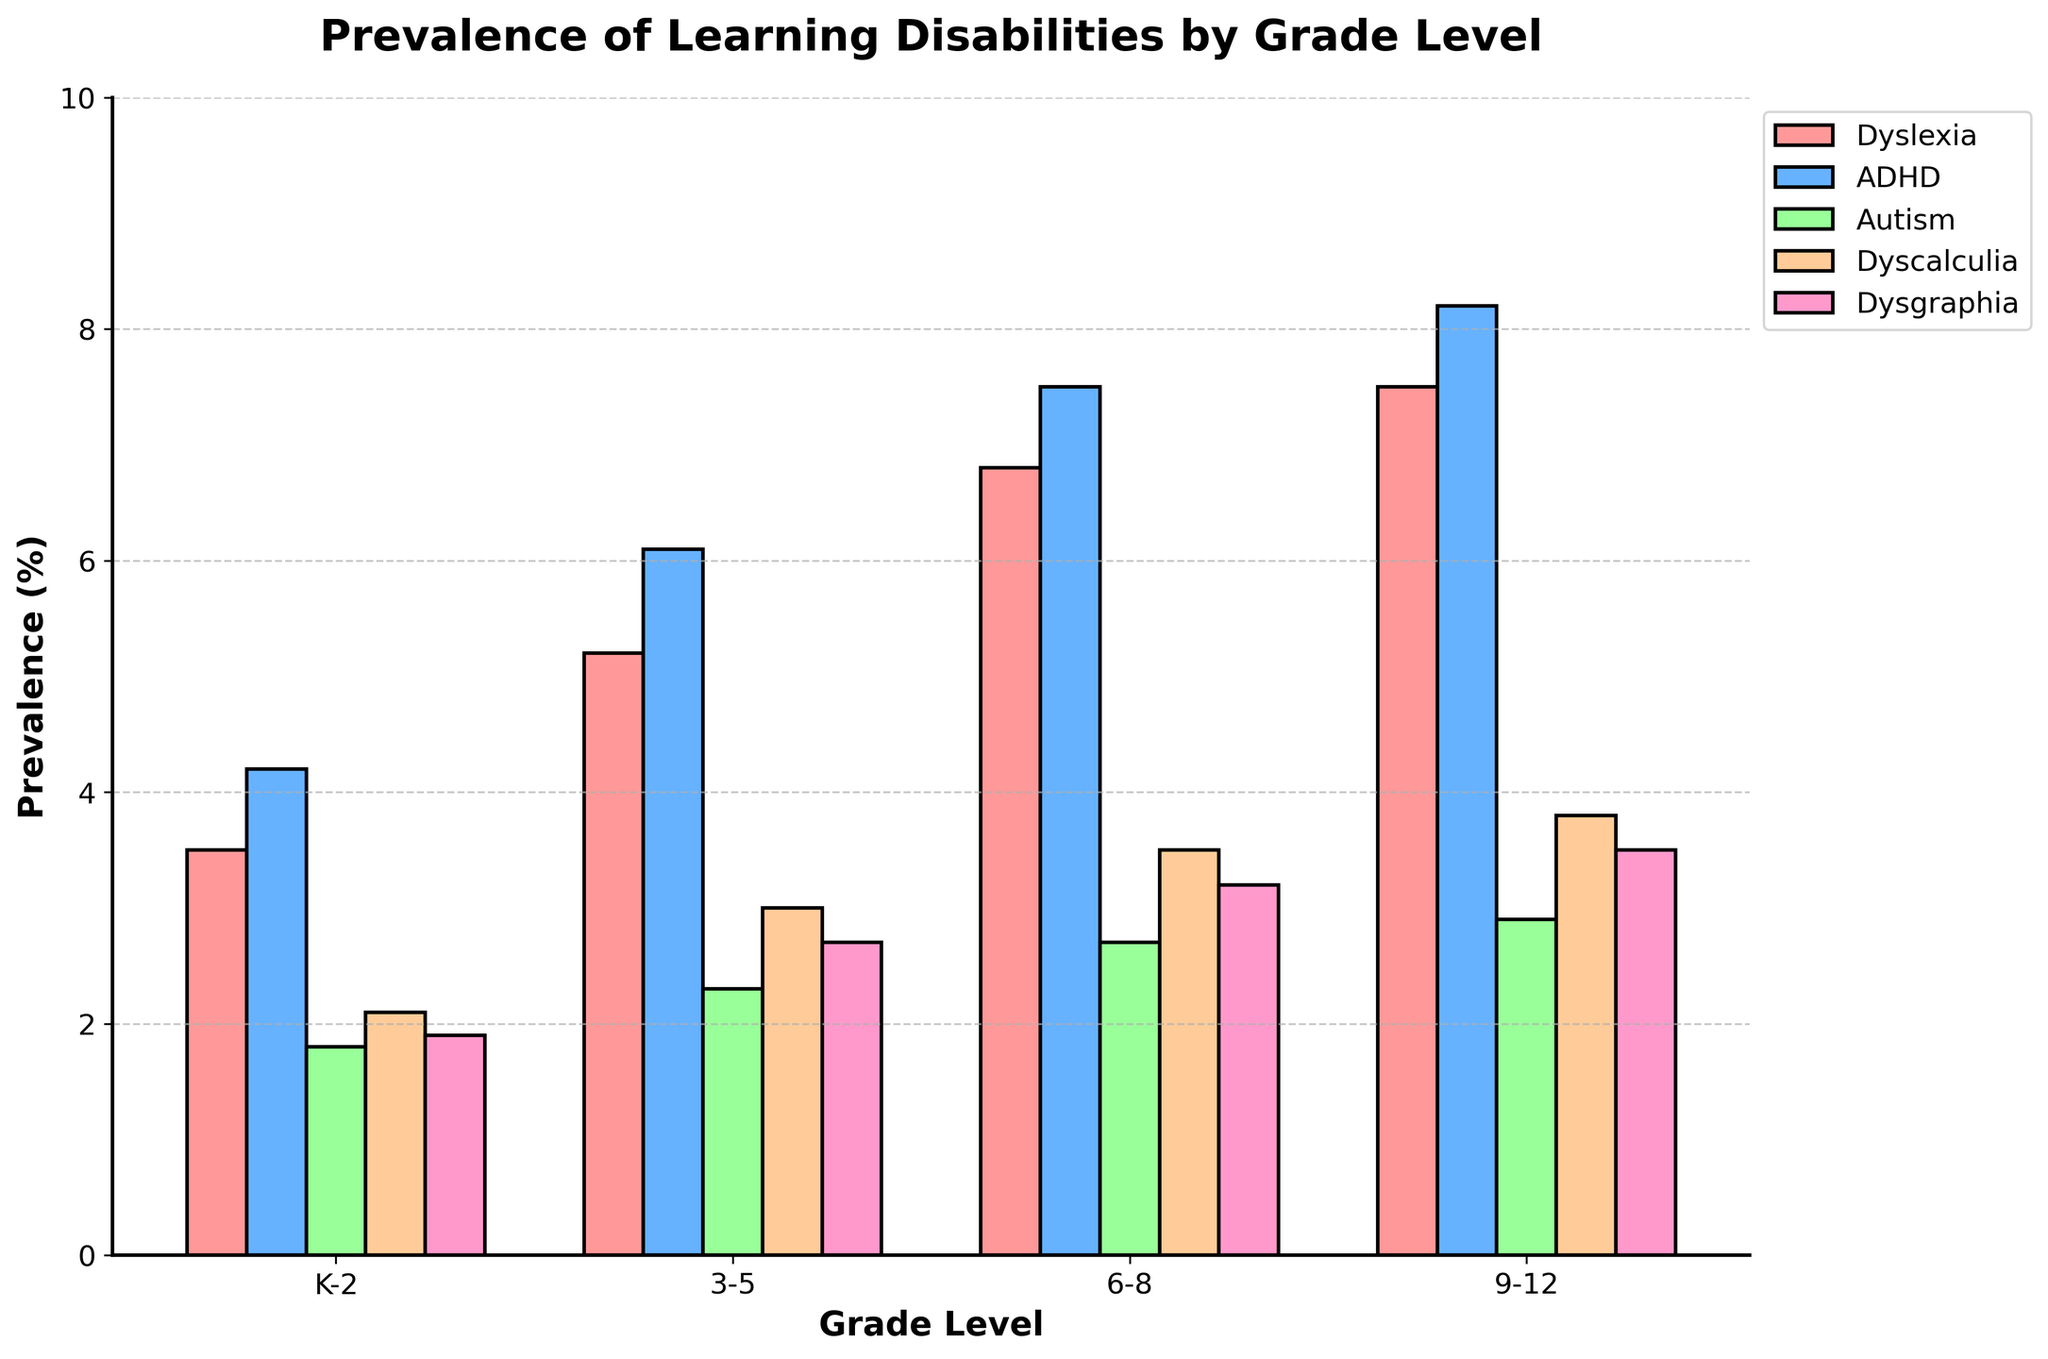What grade level has the highest prevalence of Dyslexia? By observing the height of the bars for Dyslexia across different grade levels, we see that the bar corresponding to grade level 9-12 is the tallest.
Answer: 9-12 How does the prevalence of ADHD change from grade level K-2 to 9-12? The bar for ADHD in grade level K-2 is at 4.2%, and in grade level 9-12, it is at 8.2%. Therefore, the prevalence increases by 8.2% - 4.2%, which is 4%.
Answer: 4% Compare the prevalence of Autism in grade levels K-2 and 9-12. The height of the bar for Autism in grade K-2 is 1.8%, and in grade level 9-12, it is 2.9%. Therefore, the prevalence in grade level 9-12 is higher by 2.9% - 1.8%, which is 1.1%.
Answer: 1.1% Which learning disability has the highest overall prevalence in any grade level? By comparing the highest bars across all categories, we find that the bar for ADHD in grade level 9-12 is the tallest at 8.2%.
Answer: ADHD What is the average prevalence of Dyscalculia across all grade levels? Adding up the Dyscalculia values: 2.1 + 3.0 + 3.5 + 3.8 = 12.4. There are 4 grade levels, so the average is 12.4 / 4 = 3.1%.
Answer: 3.1% Which grade level has the most evenly distributed prevalence of learning disabilities? To determine this, we observe the bars' relative heights for each disability in every grade. The grade K-2 shows the most evenly distributed heights among the disabilities.
Answer: K-2 Is there any grade level where the prevalence of Dyslexia is less than that of Dysgraphia? In each grade level, we compare the heights of the bars for Dyslexia and Dysgraphia. In all cases, the Dyslexia bar is taller than the Dysgraphia bar. So, the answer is no.
Answer: No What is the total prevalence of ADHD and Autism in grade level 6-8? The ADHD prevalence in grade 6-8 is 7.5%, while Autism is 2.7%. Adding these up: 7.5 + 2.7 = 10.2%.
Answer: 10.2% In which grade level do Dyscalculia and Dysgraphia together account for more than 6% prevalence? Summing the prevalence of Dyscalculia and Dysgraphia in each grade: 
K-2: 2.1% + 1.9% = 4%
3-5: 3.0% + 2.7% = 5.7%
6-8: 3.5% + 3.2% = 6.7%
9-12: 3.8% + 3.5% = 7.3%
Both the grades 6-8 and 9-12 have a combined prevalence higher than 6%.
Answer: 6-8 and 9-12 Between which two consecutive grade levels does Dysgraphia show the biggest increase in prevalence? To determine this, we check the differences in Dysgraphia prevalence between consecutive grade levels.
K-2 to 3-5: 2.7% - 1.9% = 0.8%
3-5 to 6-8: 3.2% - 2.7% = 0.5%
6-8 to 9-12: 3.5% - 3.2% = 0.3%
The biggest increase is from K-2 to 3-5 at 0.8%.
Answer: K-2 to 3-5 